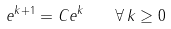Convert formula to latex. <formula><loc_0><loc_0><loc_500><loc_500>e ^ { k + 1 } = C e ^ { k } \quad \forall \, k \geq 0</formula> 